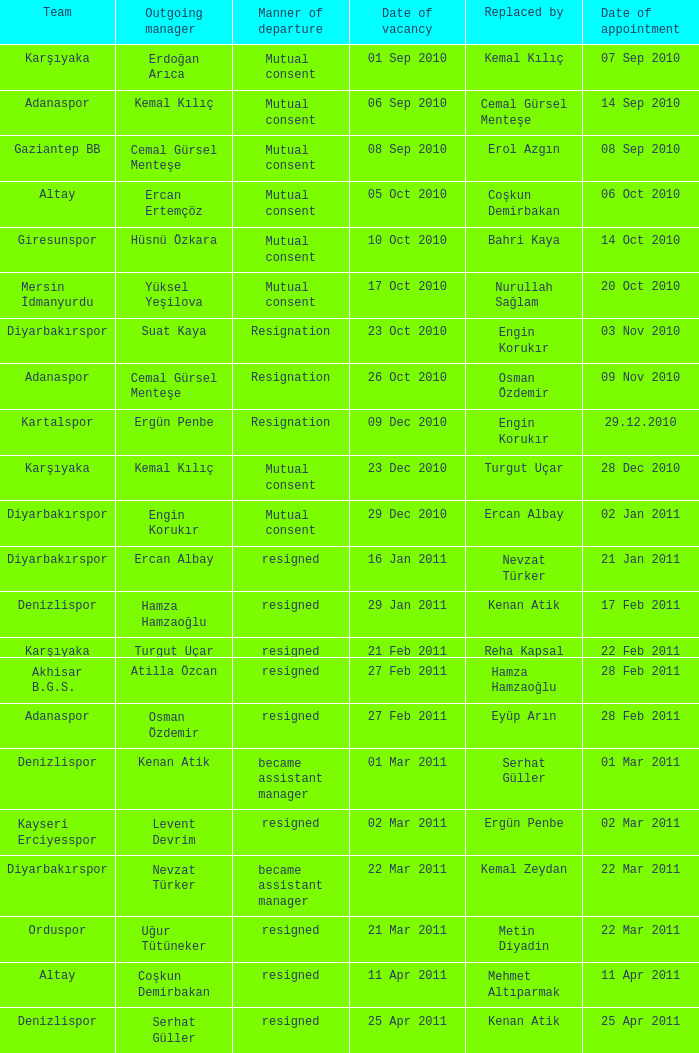Parse the full table. {'header': ['Team', 'Outgoing manager', 'Manner of departure', 'Date of vacancy', 'Replaced by', 'Date of appointment'], 'rows': [['Karşıyaka', 'Erdoğan Arıca', 'Mutual consent', '01 Sep 2010', 'Kemal Kılıç', '07 Sep 2010'], ['Adanaspor', 'Kemal Kılıç', 'Mutual consent', '06 Sep 2010', 'Cemal Gürsel Menteşe', '14 Sep 2010'], ['Gaziantep BB', 'Cemal Gürsel Menteşe', 'Mutual consent', '08 Sep 2010', 'Erol Azgın', '08 Sep 2010'], ['Altay', 'Ercan Ertemçöz', 'Mutual consent', '05 Oct 2010', 'Coşkun Demirbakan', '06 Oct 2010'], ['Giresunspor', 'Hüsnü Özkara', 'Mutual consent', '10 Oct 2010', 'Bahri Kaya', '14 Oct 2010'], ['Mersin İdmanyurdu', 'Yüksel Yeşilova', 'Mutual consent', '17 Oct 2010', 'Nurullah Sağlam', '20 Oct 2010'], ['Diyarbakırspor', 'Suat Kaya', 'Resignation', '23 Oct 2010', 'Engin Korukır', '03 Nov 2010'], ['Adanaspor', 'Cemal Gürsel Menteşe', 'Resignation', '26 Oct 2010', 'Osman Özdemir', '09 Nov 2010'], ['Kartalspor', 'Ergün Penbe', 'Resignation', '09 Dec 2010', 'Engin Korukır', '29.12.2010'], ['Karşıyaka', 'Kemal Kılıç', 'Mutual consent', '23 Dec 2010', 'Turgut Uçar', '28 Dec 2010'], ['Diyarbakırspor', 'Engin Korukır', 'Mutual consent', '29 Dec 2010', 'Ercan Albay', '02 Jan 2011'], ['Diyarbakırspor', 'Ercan Albay', 'resigned', '16 Jan 2011', 'Nevzat Türker', '21 Jan 2011'], ['Denizlispor', 'Hamza Hamzaoğlu', 'resigned', '29 Jan 2011', 'Kenan Atik', '17 Feb 2011'], ['Karşıyaka', 'Turgut Uçar', 'resigned', '21 Feb 2011', 'Reha Kapsal', '22 Feb 2011'], ['Akhisar B.G.S.', 'Atilla Özcan', 'resigned', '27 Feb 2011', 'Hamza Hamzaoğlu', '28 Feb 2011'], ['Adanaspor', 'Osman Özdemir', 'resigned', '27 Feb 2011', 'Eyüp Arın', '28 Feb 2011'], ['Denizlispor', 'Kenan Atik', 'became assistant manager', '01 Mar 2011', 'Serhat Güller', '01 Mar 2011'], ['Kayseri Erciyesspor', 'Levent Devrim', 'resigned', '02 Mar 2011', 'Ergün Penbe', '02 Mar 2011'], ['Diyarbakırspor', 'Nevzat Türker', 'became assistant manager', '22 Mar 2011', 'Kemal Zeydan', '22 Mar 2011'], ['Orduspor', 'Uğur Tütüneker', 'resigned', '21 Mar 2011', 'Metin Diyadin', '22 Mar 2011'], ['Altay', 'Coşkun Demirbakan', 'resigned', '11 Apr 2011', 'Mehmet Altıparmak', '11 Apr 2011'], ['Denizlispor', 'Serhat Güller', 'resigned', '25 Apr 2011', 'Kenan Atik', '25 Apr 2011']]} Who succeeded the departing manager hüsnü özkara? Bahri Kaya. 